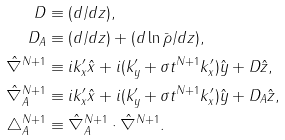<formula> <loc_0><loc_0><loc_500><loc_500>D & \equiv ( d / d z ) , \\ D _ { A } & \equiv ( d / d z ) + ( d \ln \bar { \rho } / d z ) , \\ \hat { \nabla } ^ { N + 1 } & \equiv i k ^ { \prime } _ { x } \hat { x } + i ( k ^ { \prime } _ { y } + \sigma t ^ { N + 1 } k ^ { \prime } _ { x } ) \hat { y } + D \hat { z } , \\ \hat { \nabla } _ { A } ^ { N + 1 } & \equiv i k ^ { \prime } _ { x } \hat { x } + i ( k ^ { \prime } _ { y } + \sigma t ^ { N + 1 } k ^ { \prime } _ { x } ) \hat { y } + D _ { A } \hat { z } , \\ \triangle _ { A } ^ { N + 1 } & \equiv \hat { \nabla } _ { A } ^ { N + 1 } \cdot \hat { \nabla } ^ { N + 1 } .</formula> 